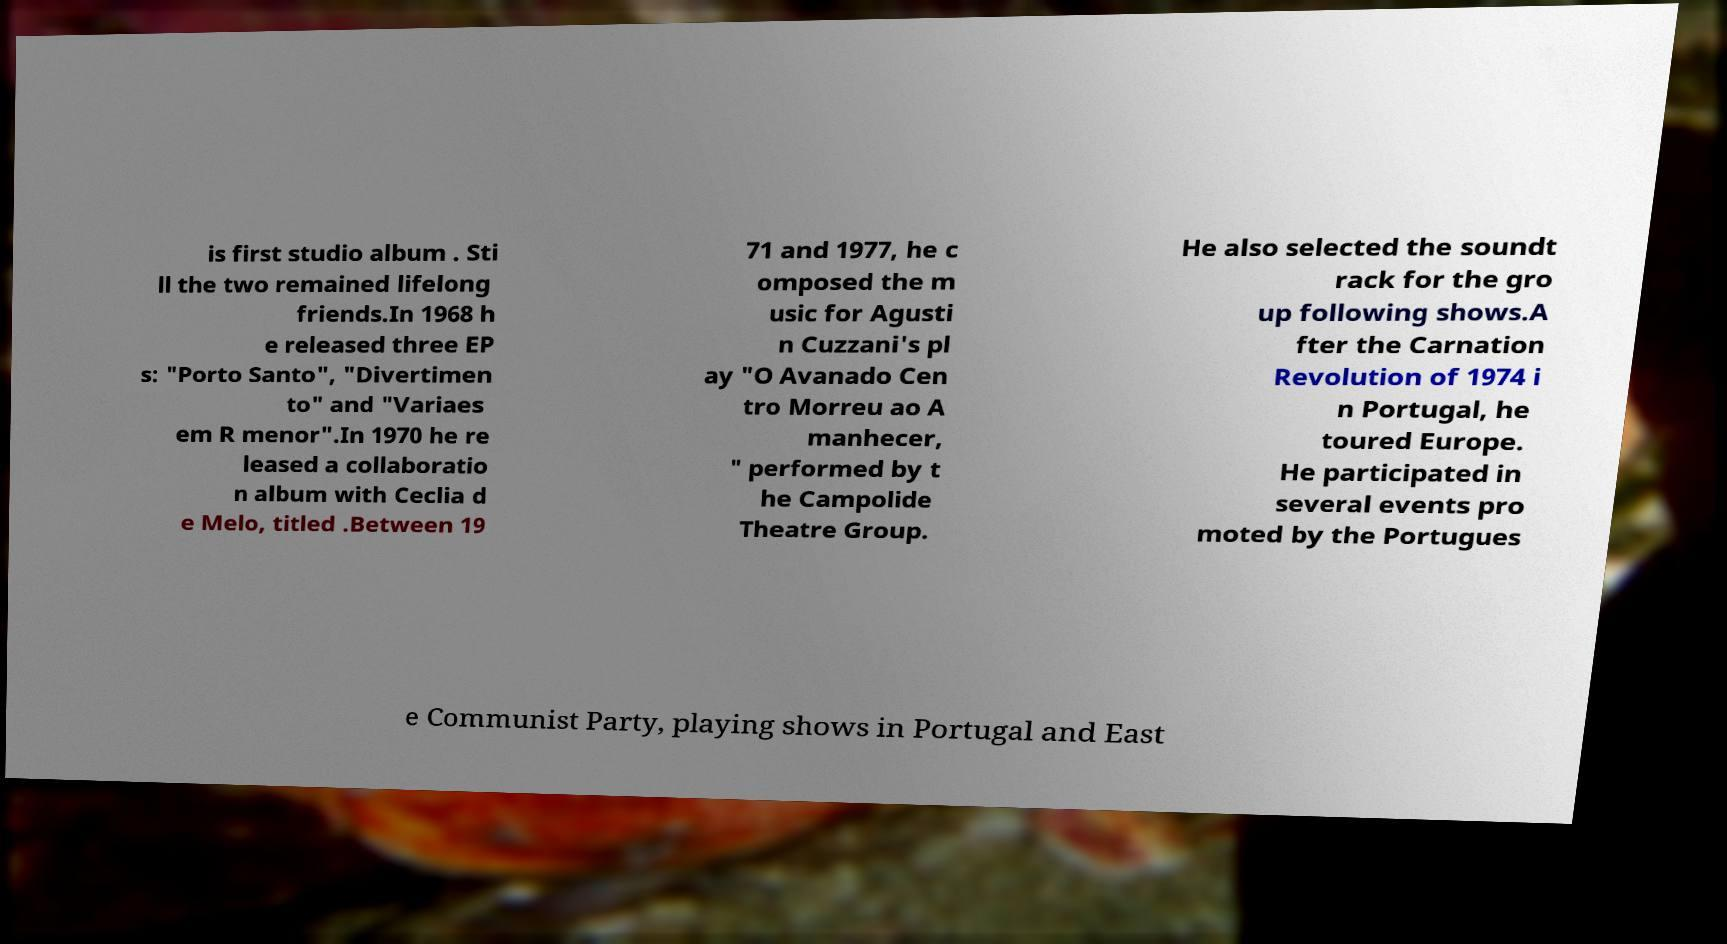Please read and relay the text visible in this image. What does it say? is first studio album . Sti ll the two remained lifelong friends.In 1968 h e released three EP s: "Porto Santo", "Divertimen to" and "Variaes em R menor".In 1970 he re leased a collaboratio n album with Ceclia d e Melo, titled .Between 19 71 and 1977, he c omposed the m usic for Agusti n Cuzzani's pl ay "O Avanado Cen tro Morreu ao A manhecer, " performed by t he Campolide Theatre Group. He also selected the soundt rack for the gro up following shows.A fter the Carnation Revolution of 1974 i n Portugal, he toured Europe. He participated in several events pro moted by the Portugues e Communist Party, playing shows in Portugal and East 